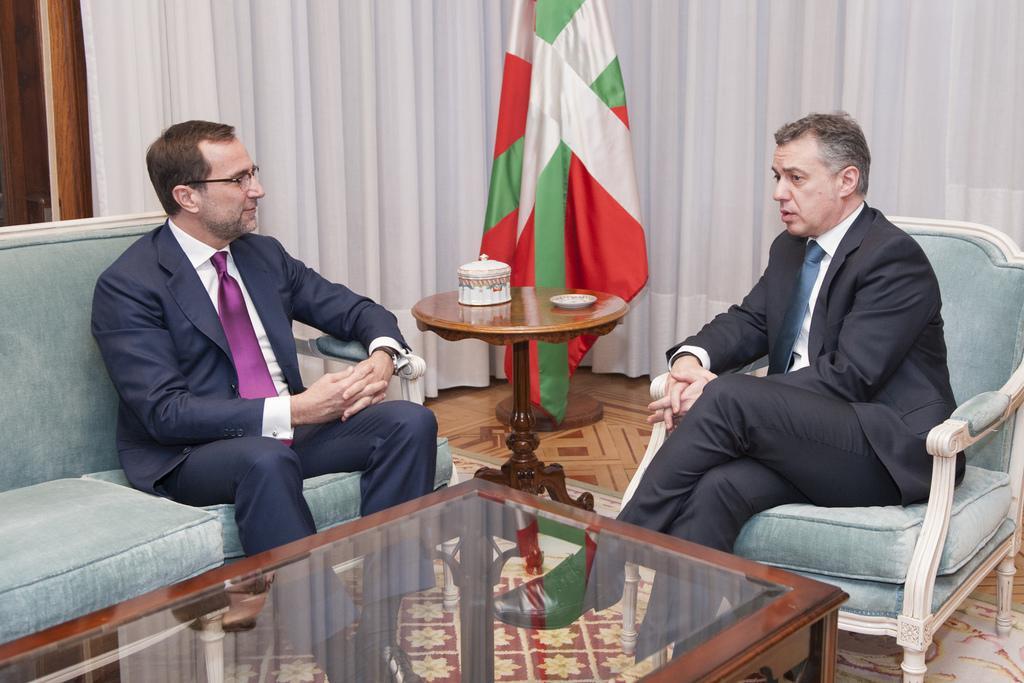In one or two sentences, can you explain what this image depicts? In this image, there are two persons wearing clothes and footwear. These two persons sitting on the chair. There is a table in front of these persons. There is a flag on the top of the center of the image. These person wearing spectacles. 